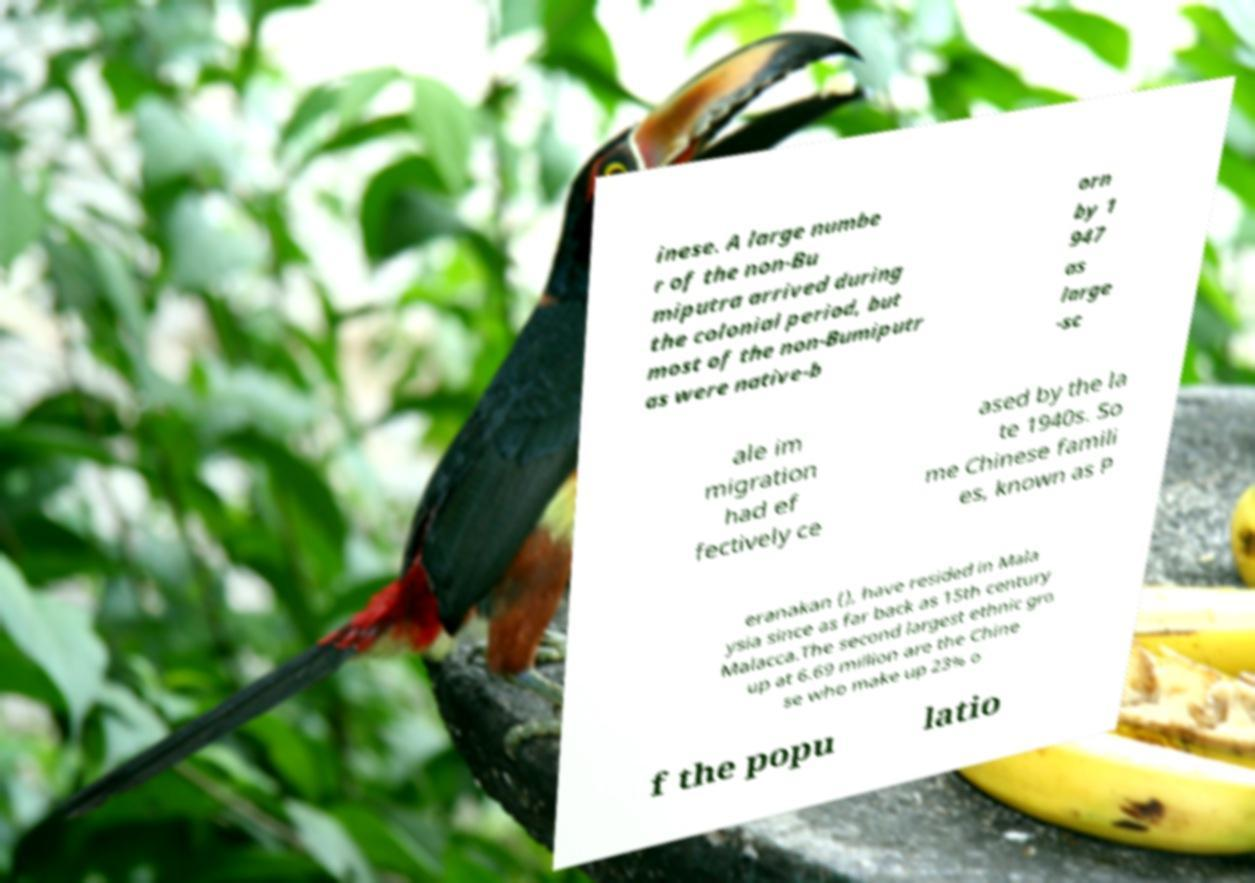Can you accurately transcribe the text from the provided image for me? inese. A large numbe r of the non-Bu miputra arrived during the colonial period, but most of the non-Bumiputr as were native-b orn by 1 947 as large -sc ale im migration had ef fectively ce ased by the la te 1940s. So me Chinese famili es, known as P eranakan (), have resided in Mala ysia since as far back as 15th century Malacca.The second largest ethnic gro up at 6.69 million are the Chine se who make up 23% o f the popu latio 